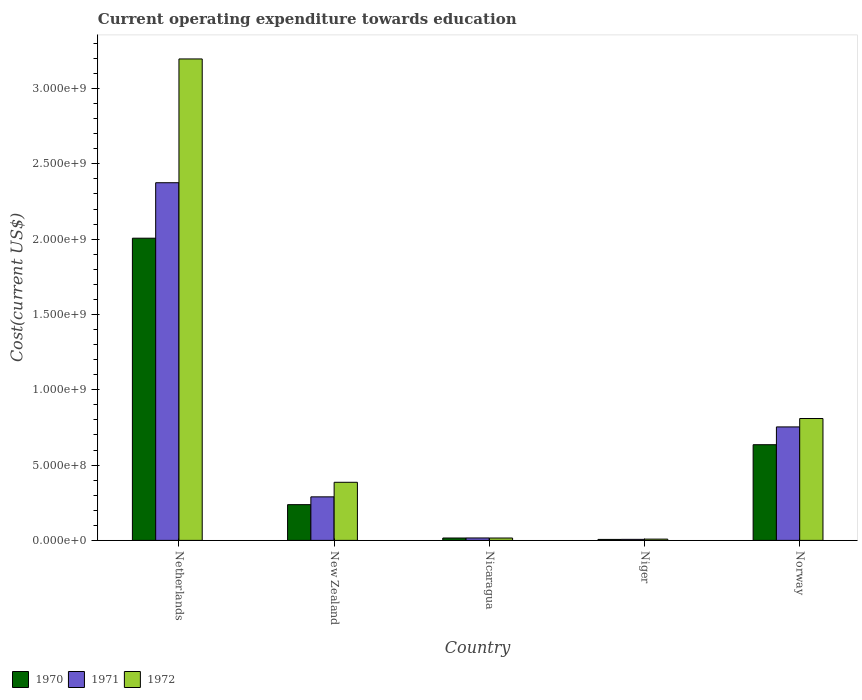How many different coloured bars are there?
Keep it short and to the point. 3. How many bars are there on the 5th tick from the left?
Provide a short and direct response. 3. How many bars are there on the 4th tick from the right?
Keep it short and to the point. 3. What is the label of the 3rd group of bars from the left?
Provide a succinct answer. Nicaragua. What is the expenditure towards education in 1972 in Niger?
Make the answer very short. 8.50e+06. Across all countries, what is the maximum expenditure towards education in 1970?
Offer a very short reply. 2.01e+09. Across all countries, what is the minimum expenditure towards education in 1971?
Give a very brief answer. 6.92e+06. In which country was the expenditure towards education in 1970 minimum?
Give a very brief answer. Niger. What is the total expenditure towards education in 1972 in the graph?
Provide a short and direct response. 4.42e+09. What is the difference between the expenditure towards education in 1972 in Netherlands and that in Norway?
Make the answer very short. 2.39e+09. What is the difference between the expenditure towards education in 1971 in New Zealand and the expenditure towards education in 1972 in Netherlands?
Your answer should be compact. -2.91e+09. What is the average expenditure towards education in 1970 per country?
Offer a terse response. 5.80e+08. What is the difference between the expenditure towards education of/in 1972 and expenditure towards education of/in 1971 in Netherlands?
Offer a terse response. 8.22e+08. What is the ratio of the expenditure towards education in 1971 in New Zealand to that in Norway?
Your answer should be compact. 0.38. Is the expenditure towards education in 1972 in Nicaragua less than that in Niger?
Keep it short and to the point. No. What is the difference between the highest and the second highest expenditure towards education in 1972?
Provide a short and direct response. 2.81e+09. What is the difference between the highest and the lowest expenditure towards education in 1971?
Ensure brevity in your answer.  2.37e+09. Is the sum of the expenditure towards education in 1970 in New Zealand and Norway greater than the maximum expenditure towards education in 1972 across all countries?
Ensure brevity in your answer.  No. How many bars are there?
Your answer should be very brief. 15. What is the difference between two consecutive major ticks on the Y-axis?
Provide a short and direct response. 5.00e+08. Are the values on the major ticks of Y-axis written in scientific E-notation?
Your response must be concise. Yes. Does the graph contain any zero values?
Your response must be concise. No. Where does the legend appear in the graph?
Ensure brevity in your answer.  Bottom left. How many legend labels are there?
Make the answer very short. 3. What is the title of the graph?
Your answer should be compact. Current operating expenditure towards education. What is the label or title of the X-axis?
Offer a terse response. Country. What is the label or title of the Y-axis?
Ensure brevity in your answer.  Cost(current US$). What is the Cost(current US$) in 1970 in Netherlands?
Keep it short and to the point. 2.01e+09. What is the Cost(current US$) in 1971 in Netherlands?
Keep it short and to the point. 2.37e+09. What is the Cost(current US$) in 1972 in Netherlands?
Your answer should be very brief. 3.20e+09. What is the Cost(current US$) of 1970 in New Zealand?
Your answer should be very brief. 2.37e+08. What is the Cost(current US$) in 1971 in New Zealand?
Ensure brevity in your answer.  2.89e+08. What is the Cost(current US$) of 1972 in New Zealand?
Your answer should be very brief. 3.86e+08. What is the Cost(current US$) of 1970 in Nicaragua?
Keep it short and to the point. 1.58e+07. What is the Cost(current US$) in 1971 in Nicaragua?
Provide a short and direct response. 1.61e+07. What is the Cost(current US$) of 1972 in Nicaragua?
Your answer should be very brief. 1.57e+07. What is the Cost(current US$) of 1970 in Niger?
Your response must be concise. 6.48e+06. What is the Cost(current US$) in 1971 in Niger?
Ensure brevity in your answer.  6.92e+06. What is the Cost(current US$) of 1972 in Niger?
Offer a very short reply. 8.50e+06. What is the Cost(current US$) in 1970 in Norway?
Offer a very short reply. 6.35e+08. What is the Cost(current US$) of 1971 in Norway?
Your answer should be very brief. 7.53e+08. What is the Cost(current US$) in 1972 in Norway?
Keep it short and to the point. 8.09e+08. Across all countries, what is the maximum Cost(current US$) in 1970?
Offer a very short reply. 2.01e+09. Across all countries, what is the maximum Cost(current US$) in 1971?
Make the answer very short. 2.37e+09. Across all countries, what is the maximum Cost(current US$) of 1972?
Offer a terse response. 3.20e+09. Across all countries, what is the minimum Cost(current US$) in 1970?
Offer a very short reply. 6.48e+06. Across all countries, what is the minimum Cost(current US$) of 1971?
Your answer should be compact. 6.92e+06. Across all countries, what is the minimum Cost(current US$) in 1972?
Your answer should be very brief. 8.50e+06. What is the total Cost(current US$) of 1970 in the graph?
Offer a very short reply. 2.90e+09. What is the total Cost(current US$) of 1971 in the graph?
Ensure brevity in your answer.  3.44e+09. What is the total Cost(current US$) of 1972 in the graph?
Give a very brief answer. 4.42e+09. What is the difference between the Cost(current US$) of 1970 in Netherlands and that in New Zealand?
Ensure brevity in your answer.  1.77e+09. What is the difference between the Cost(current US$) in 1971 in Netherlands and that in New Zealand?
Offer a very short reply. 2.09e+09. What is the difference between the Cost(current US$) of 1972 in Netherlands and that in New Zealand?
Your answer should be very brief. 2.81e+09. What is the difference between the Cost(current US$) of 1970 in Netherlands and that in Nicaragua?
Provide a short and direct response. 1.99e+09. What is the difference between the Cost(current US$) of 1971 in Netherlands and that in Nicaragua?
Offer a very short reply. 2.36e+09. What is the difference between the Cost(current US$) of 1972 in Netherlands and that in Nicaragua?
Ensure brevity in your answer.  3.18e+09. What is the difference between the Cost(current US$) of 1970 in Netherlands and that in Niger?
Give a very brief answer. 2.00e+09. What is the difference between the Cost(current US$) of 1971 in Netherlands and that in Niger?
Ensure brevity in your answer.  2.37e+09. What is the difference between the Cost(current US$) of 1972 in Netherlands and that in Niger?
Ensure brevity in your answer.  3.19e+09. What is the difference between the Cost(current US$) of 1970 in Netherlands and that in Norway?
Ensure brevity in your answer.  1.37e+09. What is the difference between the Cost(current US$) of 1971 in Netherlands and that in Norway?
Your answer should be compact. 1.62e+09. What is the difference between the Cost(current US$) in 1972 in Netherlands and that in Norway?
Make the answer very short. 2.39e+09. What is the difference between the Cost(current US$) of 1970 in New Zealand and that in Nicaragua?
Make the answer very short. 2.21e+08. What is the difference between the Cost(current US$) in 1971 in New Zealand and that in Nicaragua?
Provide a short and direct response. 2.73e+08. What is the difference between the Cost(current US$) of 1972 in New Zealand and that in Nicaragua?
Your answer should be very brief. 3.70e+08. What is the difference between the Cost(current US$) in 1970 in New Zealand and that in Niger?
Your response must be concise. 2.31e+08. What is the difference between the Cost(current US$) of 1971 in New Zealand and that in Niger?
Offer a terse response. 2.82e+08. What is the difference between the Cost(current US$) of 1972 in New Zealand and that in Niger?
Your answer should be compact. 3.77e+08. What is the difference between the Cost(current US$) in 1970 in New Zealand and that in Norway?
Your answer should be compact. -3.98e+08. What is the difference between the Cost(current US$) in 1971 in New Zealand and that in Norway?
Give a very brief answer. -4.64e+08. What is the difference between the Cost(current US$) in 1972 in New Zealand and that in Norway?
Offer a very short reply. -4.23e+08. What is the difference between the Cost(current US$) of 1970 in Nicaragua and that in Niger?
Your answer should be very brief. 9.29e+06. What is the difference between the Cost(current US$) in 1971 in Nicaragua and that in Niger?
Your answer should be compact. 9.15e+06. What is the difference between the Cost(current US$) in 1972 in Nicaragua and that in Niger?
Offer a terse response. 7.25e+06. What is the difference between the Cost(current US$) of 1970 in Nicaragua and that in Norway?
Your response must be concise. -6.19e+08. What is the difference between the Cost(current US$) in 1971 in Nicaragua and that in Norway?
Your response must be concise. -7.37e+08. What is the difference between the Cost(current US$) in 1972 in Nicaragua and that in Norway?
Make the answer very short. -7.93e+08. What is the difference between the Cost(current US$) in 1970 in Niger and that in Norway?
Your response must be concise. -6.29e+08. What is the difference between the Cost(current US$) in 1971 in Niger and that in Norway?
Provide a succinct answer. -7.46e+08. What is the difference between the Cost(current US$) in 1972 in Niger and that in Norway?
Your response must be concise. -8.01e+08. What is the difference between the Cost(current US$) of 1970 in Netherlands and the Cost(current US$) of 1971 in New Zealand?
Give a very brief answer. 1.72e+09. What is the difference between the Cost(current US$) in 1970 in Netherlands and the Cost(current US$) in 1972 in New Zealand?
Your response must be concise. 1.62e+09. What is the difference between the Cost(current US$) in 1971 in Netherlands and the Cost(current US$) in 1972 in New Zealand?
Provide a succinct answer. 1.99e+09. What is the difference between the Cost(current US$) of 1970 in Netherlands and the Cost(current US$) of 1971 in Nicaragua?
Give a very brief answer. 1.99e+09. What is the difference between the Cost(current US$) in 1970 in Netherlands and the Cost(current US$) in 1972 in Nicaragua?
Make the answer very short. 1.99e+09. What is the difference between the Cost(current US$) of 1971 in Netherlands and the Cost(current US$) of 1972 in Nicaragua?
Give a very brief answer. 2.36e+09. What is the difference between the Cost(current US$) in 1970 in Netherlands and the Cost(current US$) in 1971 in Niger?
Give a very brief answer. 2.00e+09. What is the difference between the Cost(current US$) in 1970 in Netherlands and the Cost(current US$) in 1972 in Niger?
Offer a terse response. 2.00e+09. What is the difference between the Cost(current US$) of 1971 in Netherlands and the Cost(current US$) of 1972 in Niger?
Provide a succinct answer. 2.37e+09. What is the difference between the Cost(current US$) in 1970 in Netherlands and the Cost(current US$) in 1971 in Norway?
Provide a short and direct response. 1.25e+09. What is the difference between the Cost(current US$) in 1970 in Netherlands and the Cost(current US$) in 1972 in Norway?
Offer a terse response. 1.20e+09. What is the difference between the Cost(current US$) in 1971 in Netherlands and the Cost(current US$) in 1972 in Norway?
Make the answer very short. 1.57e+09. What is the difference between the Cost(current US$) of 1970 in New Zealand and the Cost(current US$) of 1971 in Nicaragua?
Offer a terse response. 2.21e+08. What is the difference between the Cost(current US$) in 1970 in New Zealand and the Cost(current US$) in 1972 in Nicaragua?
Provide a succinct answer. 2.22e+08. What is the difference between the Cost(current US$) in 1971 in New Zealand and the Cost(current US$) in 1972 in Nicaragua?
Make the answer very short. 2.73e+08. What is the difference between the Cost(current US$) of 1970 in New Zealand and the Cost(current US$) of 1971 in Niger?
Provide a short and direct response. 2.30e+08. What is the difference between the Cost(current US$) of 1970 in New Zealand and the Cost(current US$) of 1972 in Niger?
Your response must be concise. 2.29e+08. What is the difference between the Cost(current US$) in 1971 in New Zealand and the Cost(current US$) in 1972 in Niger?
Provide a short and direct response. 2.81e+08. What is the difference between the Cost(current US$) of 1970 in New Zealand and the Cost(current US$) of 1971 in Norway?
Ensure brevity in your answer.  -5.16e+08. What is the difference between the Cost(current US$) in 1970 in New Zealand and the Cost(current US$) in 1972 in Norway?
Your answer should be compact. -5.72e+08. What is the difference between the Cost(current US$) of 1971 in New Zealand and the Cost(current US$) of 1972 in Norway?
Provide a short and direct response. -5.20e+08. What is the difference between the Cost(current US$) in 1970 in Nicaragua and the Cost(current US$) in 1971 in Niger?
Your response must be concise. 8.85e+06. What is the difference between the Cost(current US$) in 1970 in Nicaragua and the Cost(current US$) in 1972 in Niger?
Offer a very short reply. 7.28e+06. What is the difference between the Cost(current US$) of 1971 in Nicaragua and the Cost(current US$) of 1972 in Niger?
Provide a succinct answer. 7.58e+06. What is the difference between the Cost(current US$) in 1970 in Nicaragua and the Cost(current US$) in 1971 in Norway?
Your answer should be very brief. -7.38e+08. What is the difference between the Cost(current US$) of 1970 in Nicaragua and the Cost(current US$) of 1972 in Norway?
Offer a very short reply. -7.93e+08. What is the difference between the Cost(current US$) in 1971 in Nicaragua and the Cost(current US$) in 1972 in Norway?
Ensure brevity in your answer.  -7.93e+08. What is the difference between the Cost(current US$) in 1970 in Niger and the Cost(current US$) in 1971 in Norway?
Make the answer very short. -7.47e+08. What is the difference between the Cost(current US$) of 1970 in Niger and the Cost(current US$) of 1972 in Norway?
Keep it short and to the point. -8.03e+08. What is the difference between the Cost(current US$) in 1971 in Niger and the Cost(current US$) in 1972 in Norway?
Your answer should be compact. -8.02e+08. What is the average Cost(current US$) of 1970 per country?
Provide a succinct answer. 5.80e+08. What is the average Cost(current US$) of 1971 per country?
Provide a short and direct response. 6.88e+08. What is the average Cost(current US$) of 1972 per country?
Offer a very short reply. 8.83e+08. What is the difference between the Cost(current US$) of 1970 and Cost(current US$) of 1971 in Netherlands?
Your answer should be very brief. -3.68e+08. What is the difference between the Cost(current US$) of 1970 and Cost(current US$) of 1972 in Netherlands?
Offer a terse response. -1.19e+09. What is the difference between the Cost(current US$) of 1971 and Cost(current US$) of 1972 in Netherlands?
Give a very brief answer. -8.22e+08. What is the difference between the Cost(current US$) of 1970 and Cost(current US$) of 1971 in New Zealand?
Ensure brevity in your answer.  -5.18e+07. What is the difference between the Cost(current US$) in 1970 and Cost(current US$) in 1972 in New Zealand?
Offer a terse response. -1.49e+08. What is the difference between the Cost(current US$) in 1971 and Cost(current US$) in 1972 in New Zealand?
Make the answer very short. -9.67e+07. What is the difference between the Cost(current US$) of 1970 and Cost(current US$) of 1971 in Nicaragua?
Offer a terse response. -3.03e+05. What is the difference between the Cost(current US$) of 1970 and Cost(current US$) of 1972 in Nicaragua?
Your response must be concise. 3.08e+04. What is the difference between the Cost(current US$) in 1971 and Cost(current US$) in 1972 in Nicaragua?
Your answer should be very brief. 3.34e+05. What is the difference between the Cost(current US$) of 1970 and Cost(current US$) of 1971 in Niger?
Offer a very short reply. -4.39e+05. What is the difference between the Cost(current US$) in 1970 and Cost(current US$) in 1972 in Niger?
Ensure brevity in your answer.  -2.01e+06. What is the difference between the Cost(current US$) in 1971 and Cost(current US$) in 1972 in Niger?
Provide a succinct answer. -1.57e+06. What is the difference between the Cost(current US$) of 1970 and Cost(current US$) of 1971 in Norway?
Ensure brevity in your answer.  -1.18e+08. What is the difference between the Cost(current US$) of 1970 and Cost(current US$) of 1972 in Norway?
Your answer should be very brief. -1.74e+08. What is the difference between the Cost(current US$) in 1971 and Cost(current US$) in 1972 in Norway?
Make the answer very short. -5.58e+07. What is the ratio of the Cost(current US$) of 1970 in Netherlands to that in New Zealand?
Make the answer very short. 8.46. What is the ratio of the Cost(current US$) of 1971 in Netherlands to that in New Zealand?
Provide a short and direct response. 8.21. What is the ratio of the Cost(current US$) in 1972 in Netherlands to that in New Zealand?
Provide a short and direct response. 8.29. What is the ratio of the Cost(current US$) of 1970 in Netherlands to that in Nicaragua?
Ensure brevity in your answer.  127.19. What is the ratio of the Cost(current US$) in 1971 in Netherlands to that in Nicaragua?
Ensure brevity in your answer.  147.7. What is the ratio of the Cost(current US$) in 1972 in Netherlands to that in Nicaragua?
Ensure brevity in your answer.  203.04. What is the ratio of the Cost(current US$) in 1970 in Netherlands to that in Niger?
Ensure brevity in your answer.  309.42. What is the ratio of the Cost(current US$) in 1971 in Netherlands to that in Niger?
Keep it short and to the point. 343.01. What is the ratio of the Cost(current US$) of 1972 in Netherlands to that in Niger?
Offer a very short reply. 376.23. What is the ratio of the Cost(current US$) in 1970 in Netherlands to that in Norway?
Give a very brief answer. 3.16. What is the ratio of the Cost(current US$) of 1971 in Netherlands to that in Norway?
Provide a short and direct response. 3.15. What is the ratio of the Cost(current US$) in 1972 in Netherlands to that in Norway?
Your answer should be very brief. 3.95. What is the ratio of the Cost(current US$) of 1970 in New Zealand to that in Nicaragua?
Provide a short and direct response. 15.04. What is the ratio of the Cost(current US$) in 1971 in New Zealand to that in Nicaragua?
Offer a very short reply. 17.98. What is the ratio of the Cost(current US$) in 1972 in New Zealand to that in Nicaragua?
Your response must be concise. 24.51. What is the ratio of the Cost(current US$) in 1970 in New Zealand to that in Niger?
Make the answer very short. 36.59. What is the ratio of the Cost(current US$) of 1971 in New Zealand to that in Niger?
Your answer should be compact. 41.76. What is the ratio of the Cost(current US$) of 1972 in New Zealand to that in Niger?
Offer a terse response. 45.41. What is the ratio of the Cost(current US$) of 1970 in New Zealand to that in Norway?
Provide a succinct answer. 0.37. What is the ratio of the Cost(current US$) in 1971 in New Zealand to that in Norway?
Offer a very short reply. 0.38. What is the ratio of the Cost(current US$) of 1972 in New Zealand to that in Norway?
Ensure brevity in your answer.  0.48. What is the ratio of the Cost(current US$) in 1970 in Nicaragua to that in Niger?
Offer a very short reply. 2.43. What is the ratio of the Cost(current US$) of 1971 in Nicaragua to that in Niger?
Offer a terse response. 2.32. What is the ratio of the Cost(current US$) in 1972 in Nicaragua to that in Niger?
Your response must be concise. 1.85. What is the ratio of the Cost(current US$) of 1970 in Nicaragua to that in Norway?
Offer a very short reply. 0.02. What is the ratio of the Cost(current US$) in 1971 in Nicaragua to that in Norway?
Offer a terse response. 0.02. What is the ratio of the Cost(current US$) of 1972 in Nicaragua to that in Norway?
Give a very brief answer. 0.02. What is the ratio of the Cost(current US$) of 1970 in Niger to that in Norway?
Offer a terse response. 0.01. What is the ratio of the Cost(current US$) in 1971 in Niger to that in Norway?
Your response must be concise. 0.01. What is the ratio of the Cost(current US$) in 1972 in Niger to that in Norway?
Your answer should be very brief. 0.01. What is the difference between the highest and the second highest Cost(current US$) in 1970?
Provide a succinct answer. 1.37e+09. What is the difference between the highest and the second highest Cost(current US$) in 1971?
Give a very brief answer. 1.62e+09. What is the difference between the highest and the second highest Cost(current US$) of 1972?
Your response must be concise. 2.39e+09. What is the difference between the highest and the lowest Cost(current US$) of 1970?
Provide a short and direct response. 2.00e+09. What is the difference between the highest and the lowest Cost(current US$) of 1971?
Ensure brevity in your answer.  2.37e+09. What is the difference between the highest and the lowest Cost(current US$) in 1972?
Your answer should be very brief. 3.19e+09. 